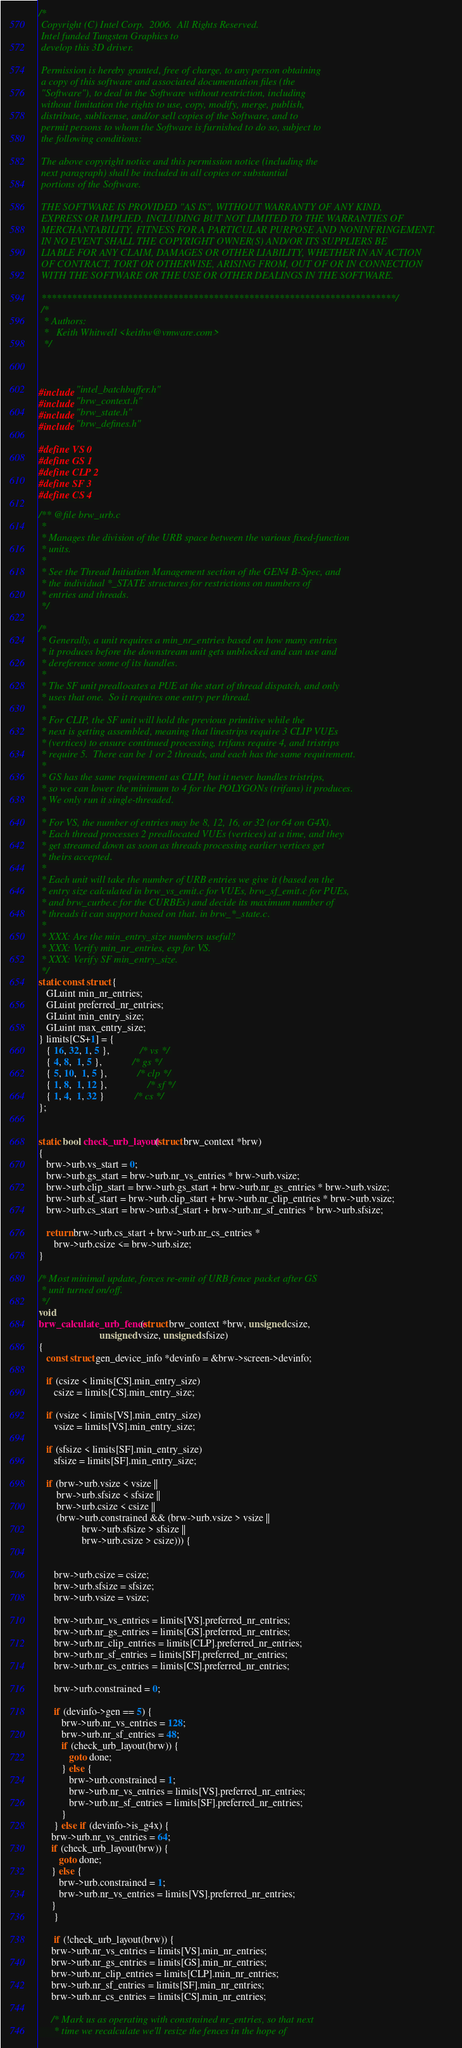Convert code to text. <code><loc_0><loc_0><loc_500><loc_500><_C_>/*
 Copyright (C) Intel Corp.  2006.  All Rights Reserved.
 Intel funded Tungsten Graphics to
 develop this 3D driver.

 Permission is hereby granted, free of charge, to any person obtaining
 a copy of this software and associated documentation files (the
 "Software"), to deal in the Software without restriction, including
 without limitation the rights to use, copy, modify, merge, publish,
 distribute, sublicense, and/or sell copies of the Software, and to
 permit persons to whom the Software is furnished to do so, subject to
 the following conditions:

 The above copyright notice and this permission notice (including the
 next paragraph) shall be included in all copies or substantial
 portions of the Software.

 THE SOFTWARE IS PROVIDED "AS IS", WITHOUT WARRANTY OF ANY KIND,
 EXPRESS OR IMPLIED, INCLUDING BUT NOT LIMITED TO THE WARRANTIES OF
 MERCHANTABILITY, FITNESS FOR A PARTICULAR PURPOSE AND NONINFRINGEMENT.
 IN NO EVENT SHALL THE COPYRIGHT OWNER(S) AND/OR ITS SUPPLIERS BE
 LIABLE FOR ANY CLAIM, DAMAGES OR OTHER LIABILITY, WHETHER IN AN ACTION
 OF CONTRACT, TORT OR OTHERWISE, ARISING FROM, OUT OF OR IN CONNECTION
 WITH THE SOFTWARE OR THE USE OR OTHER DEALINGS IN THE SOFTWARE.

 **********************************************************************/
 /*
  * Authors:
  *   Keith Whitwell <keithw@vmware.com>
  */



#include "intel_batchbuffer.h"
#include "brw_context.h"
#include "brw_state.h"
#include "brw_defines.h"

#define VS 0
#define GS 1
#define CLP 2
#define SF 3
#define CS 4

/** @file brw_urb.c
 *
 * Manages the division of the URB space between the various fixed-function
 * units.
 *
 * See the Thread Initiation Management section of the GEN4 B-Spec, and
 * the individual *_STATE structures for restrictions on numbers of
 * entries and threads.
 */

/*
 * Generally, a unit requires a min_nr_entries based on how many entries
 * it produces before the downstream unit gets unblocked and can use and
 * dereference some of its handles.
 *
 * The SF unit preallocates a PUE at the start of thread dispatch, and only
 * uses that one.  So it requires one entry per thread.
 *
 * For CLIP, the SF unit will hold the previous primitive while the
 * next is getting assembled, meaning that linestrips require 3 CLIP VUEs
 * (vertices) to ensure continued processing, trifans require 4, and tristrips
 * require 5.  There can be 1 or 2 threads, and each has the same requirement.
 *
 * GS has the same requirement as CLIP, but it never handles tristrips,
 * so we can lower the minimum to 4 for the POLYGONs (trifans) it produces.
 * We only run it single-threaded.
 *
 * For VS, the number of entries may be 8, 12, 16, or 32 (or 64 on G4X).
 * Each thread processes 2 preallocated VUEs (vertices) at a time, and they
 * get streamed down as soon as threads processing earlier vertices get
 * theirs accepted.
 *
 * Each unit will take the number of URB entries we give it (based on the
 * entry size calculated in brw_vs_emit.c for VUEs, brw_sf_emit.c for PUEs,
 * and brw_curbe.c for the CURBEs) and decide its maximum number of
 * threads it can support based on that. in brw_*_state.c.
 *
 * XXX: Are the min_entry_size numbers useful?
 * XXX: Verify min_nr_entries, esp for VS.
 * XXX: Verify SF min_entry_size.
 */
static const struct {
   GLuint min_nr_entries;
   GLuint preferred_nr_entries;
   GLuint min_entry_size;
   GLuint max_entry_size;
} limits[CS+1] = {
   { 16, 32, 1, 5 },			/* vs */
   { 4, 8,  1, 5 },			/* gs */
   { 5, 10,  1, 5 },			/* clp */
   { 1, 8,  1, 12 },		        /* sf */
   { 1, 4,  1, 32 }			/* cs */
};


static bool check_urb_layout(struct brw_context *brw)
{
   brw->urb.vs_start = 0;
   brw->urb.gs_start = brw->urb.nr_vs_entries * brw->urb.vsize;
   brw->urb.clip_start = brw->urb.gs_start + brw->urb.nr_gs_entries * brw->urb.vsize;
   brw->urb.sf_start = brw->urb.clip_start + brw->urb.nr_clip_entries * brw->urb.vsize;
   brw->urb.cs_start = brw->urb.sf_start + brw->urb.nr_sf_entries * brw->urb.sfsize;

   return brw->urb.cs_start + brw->urb.nr_cs_entries *
      brw->urb.csize <= brw->urb.size;
}

/* Most minimal update, forces re-emit of URB fence packet after GS
 * unit turned on/off.
 */
void
brw_calculate_urb_fence(struct brw_context *brw, unsigned csize,
                        unsigned vsize, unsigned sfsize)
{
   const struct gen_device_info *devinfo = &brw->screen->devinfo;

   if (csize < limits[CS].min_entry_size)
      csize = limits[CS].min_entry_size;

   if (vsize < limits[VS].min_entry_size)
      vsize = limits[VS].min_entry_size;

   if (sfsize < limits[SF].min_entry_size)
      sfsize = limits[SF].min_entry_size;

   if (brw->urb.vsize < vsize ||
       brw->urb.sfsize < sfsize ||
       brw->urb.csize < csize ||
       (brw->urb.constrained && (brw->urb.vsize > vsize ||
				 brw->urb.sfsize > sfsize ||
				 brw->urb.csize > csize))) {


      brw->urb.csize = csize;
      brw->urb.sfsize = sfsize;
      brw->urb.vsize = vsize;

      brw->urb.nr_vs_entries = limits[VS].preferred_nr_entries;
      brw->urb.nr_gs_entries = limits[GS].preferred_nr_entries;
      brw->urb.nr_clip_entries = limits[CLP].preferred_nr_entries;
      brw->urb.nr_sf_entries = limits[SF].preferred_nr_entries;
      brw->urb.nr_cs_entries = limits[CS].preferred_nr_entries;

      brw->urb.constrained = 0;

      if (devinfo->gen == 5) {
         brw->urb.nr_vs_entries = 128;
         brw->urb.nr_sf_entries = 48;
         if (check_urb_layout(brw)) {
            goto done;
         } else {
            brw->urb.constrained = 1;
            brw->urb.nr_vs_entries = limits[VS].preferred_nr_entries;
            brw->urb.nr_sf_entries = limits[SF].preferred_nr_entries;
         }
      } else if (devinfo->is_g4x) {
	 brw->urb.nr_vs_entries = 64;
	 if (check_urb_layout(brw)) {
	    goto done;
	 } else {
	    brw->urb.constrained = 1;
	    brw->urb.nr_vs_entries = limits[VS].preferred_nr_entries;
	 }
      }

      if (!check_urb_layout(brw)) {
	 brw->urb.nr_vs_entries = limits[VS].min_nr_entries;
	 brw->urb.nr_gs_entries = limits[GS].min_nr_entries;
	 brw->urb.nr_clip_entries = limits[CLP].min_nr_entries;
	 brw->urb.nr_sf_entries = limits[SF].min_nr_entries;
	 brw->urb.nr_cs_entries = limits[CS].min_nr_entries;

	 /* Mark us as operating with constrained nr_entries, so that next
	  * time we recalculate we'll resize the fences in the hope of</code> 